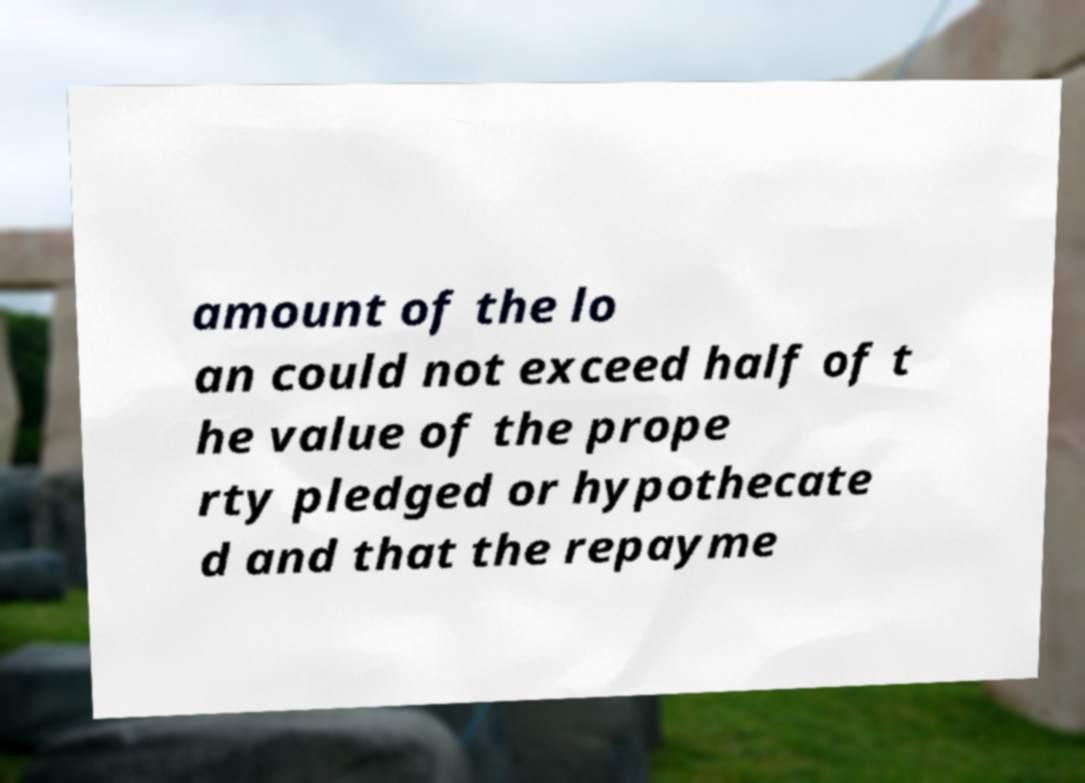Please read and relay the text visible in this image. What does it say? amount of the lo an could not exceed half of t he value of the prope rty pledged or hypothecate d and that the repayme 